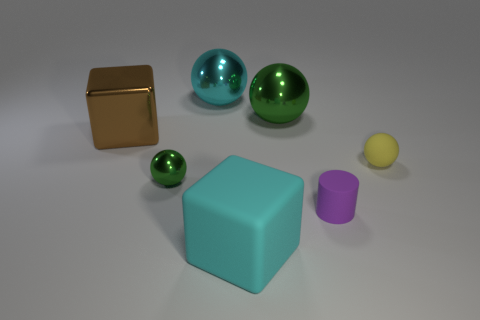There is a big cyan rubber block; are there any metallic balls right of it?
Ensure brevity in your answer.  Yes. There is a large object that is in front of the tiny rubber cylinder; how many cyan rubber objects are to the right of it?
Offer a terse response. 0. There is a green object that is the same size as the yellow matte sphere; what is its material?
Offer a very short reply. Metal. What number of other things are there of the same material as the large brown block
Ensure brevity in your answer.  3. How many metallic balls are on the right side of the small metal sphere?
Ensure brevity in your answer.  2. How many cylinders are small rubber objects or big yellow metal objects?
Your response must be concise. 1. What size is the thing that is both left of the small cylinder and in front of the small green shiny object?
Offer a very short reply. Large. How many other objects are the same color as the small rubber cylinder?
Ensure brevity in your answer.  0. Does the small yellow sphere have the same material as the big cyan thing that is behind the small green ball?
Ensure brevity in your answer.  No. How many things are either shiny blocks that are left of the rubber block or large metallic spheres?
Make the answer very short. 3. 